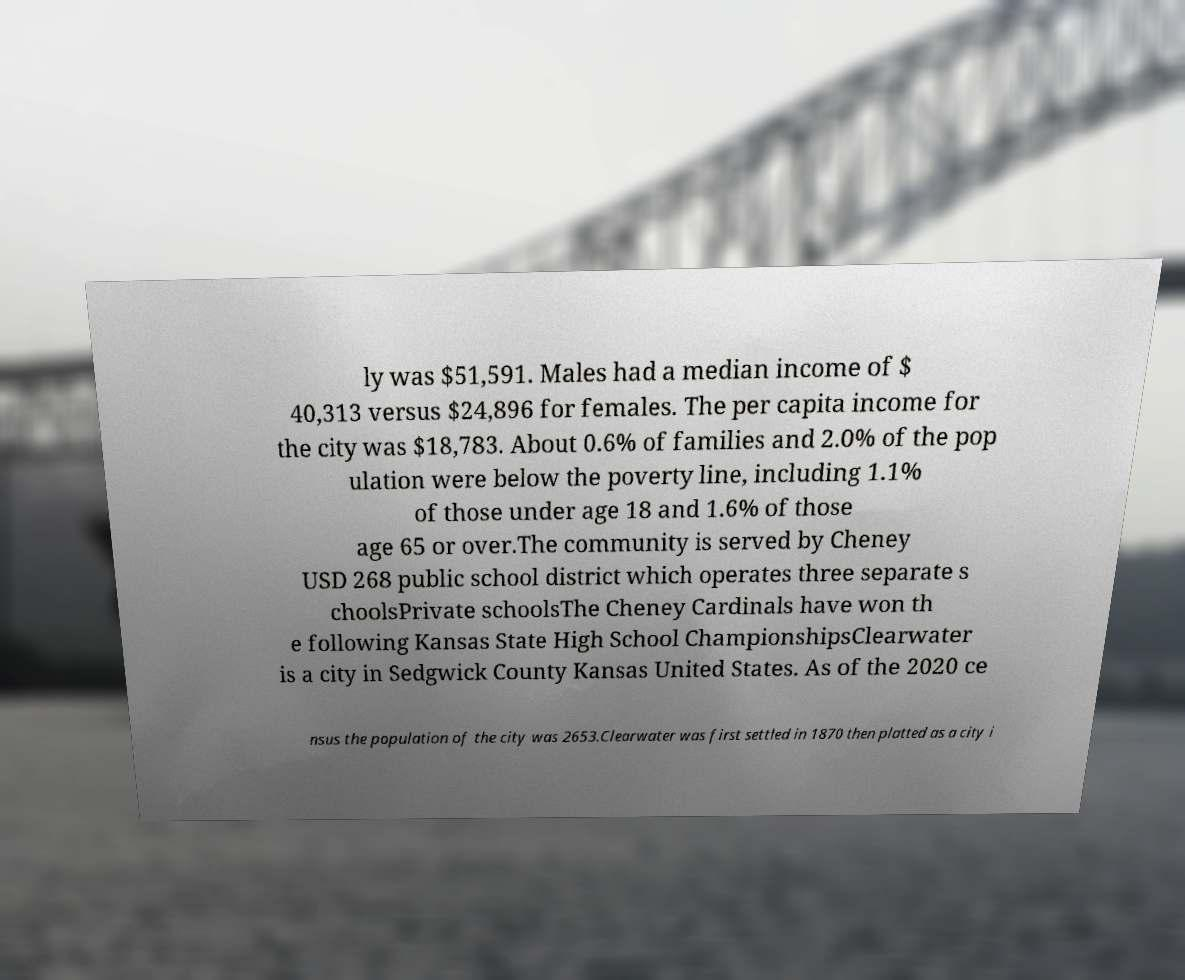I need the written content from this picture converted into text. Can you do that? ly was $51,591. Males had a median income of $ 40,313 versus $24,896 for females. The per capita income for the city was $18,783. About 0.6% of families and 2.0% of the pop ulation were below the poverty line, including 1.1% of those under age 18 and 1.6% of those age 65 or over.The community is served by Cheney USD 268 public school district which operates three separate s choolsPrivate schoolsThe Cheney Cardinals have won th e following Kansas State High School ChampionshipsClearwater is a city in Sedgwick County Kansas United States. As of the 2020 ce nsus the population of the city was 2653.Clearwater was first settled in 1870 then platted as a city i 